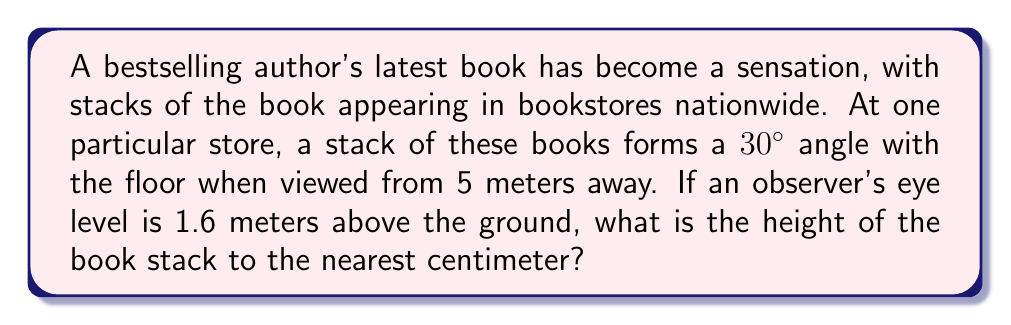Teach me how to tackle this problem. Let's approach this step-by-step using trigonometry:

1) First, we need to visualize the problem. We have a right triangle where:
   - The eye level of the observer is the height of one side (1.6 m)
   - The distance from the observer to the stack is the base (5 m)
   - The angle between the floor and the line of sight is 30°
   - The height of the stack is what we're trying to find

2) We can use the tangent ratio to solve this. Tangent is the ratio of the opposite side to the adjacent side in a right triangle.

3) In this case:
   $$ \tan(30°) = \frac{\text{stack height} - 1.6 \text{ m}}{5 \text{ m}} $$

4) We know that $\tan(30°) = \frac{1}{\sqrt{3}} \approx 0.5774$

5) Let's substitute this into our equation:
   $$ 0.5774 = \frac{\text{stack height} - 1.6 \text{ m}}{5 \text{ m}} $$

6) Now we can solve for the stack height:
   $$ 0.5774 * 5 \text{ m} = \text{stack height} - 1.6 \text{ m} $$
   $$ 2.887 \text{ m} = \text{stack height} - 1.6 \text{ m} $$
   $$ \text{stack height} = 2.887 \text{ m} + 1.6 \text{ m} = 4.487 \text{ m} $$

7) Rounding to the nearest centimeter:
   $$ \text{stack height} \approx 4.49 \text{ m} = 449 \text{ cm} $$
Answer: 449 cm 